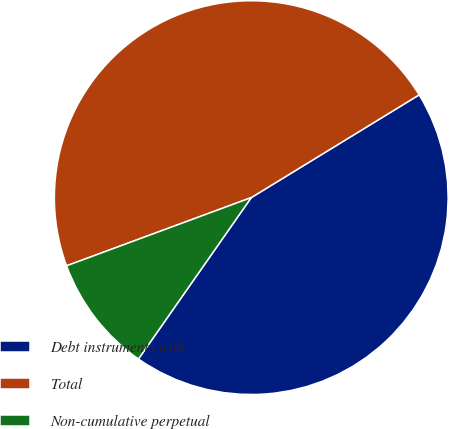<chart> <loc_0><loc_0><loc_500><loc_500><pie_chart><fcel>Debt instruments with<fcel>Total<fcel>Non-cumulative perpetual<nl><fcel>43.45%<fcel>46.89%<fcel>9.66%<nl></chart> 